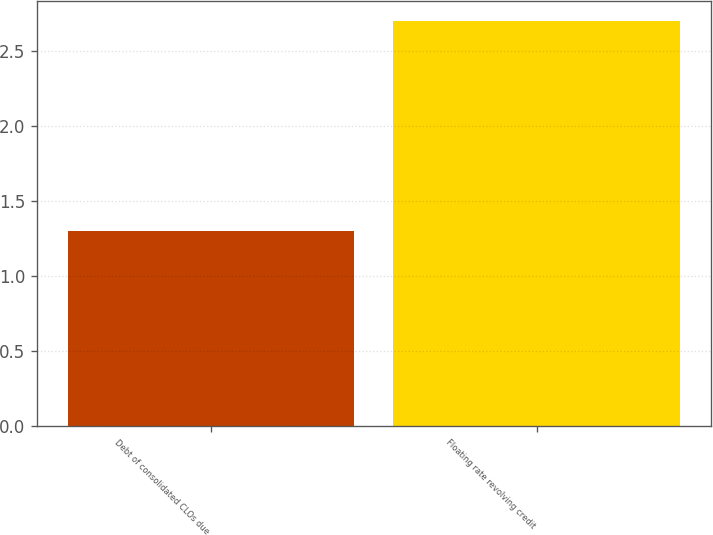Convert chart. <chart><loc_0><loc_0><loc_500><loc_500><bar_chart><fcel>Debt of consolidated CLOs due<fcel>Floating rate revolving credit<nl><fcel>1.3<fcel>2.7<nl></chart> 